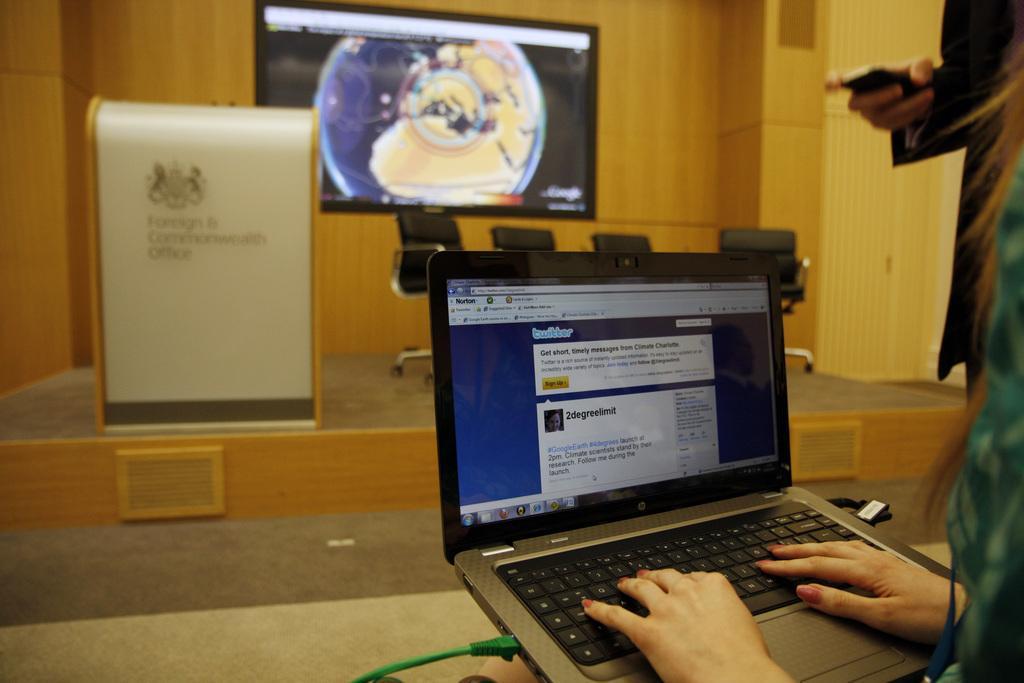In one or two sentences, can you explain what this image depicts? In the image there is a person working with the laptop and beside that person there is another person standing and in front of them there is a stage and on the stage there are four empty chairs, a table and in the background there is a projector screen and something is being displayed on the screen and behind that screen there is a wooden wall. 